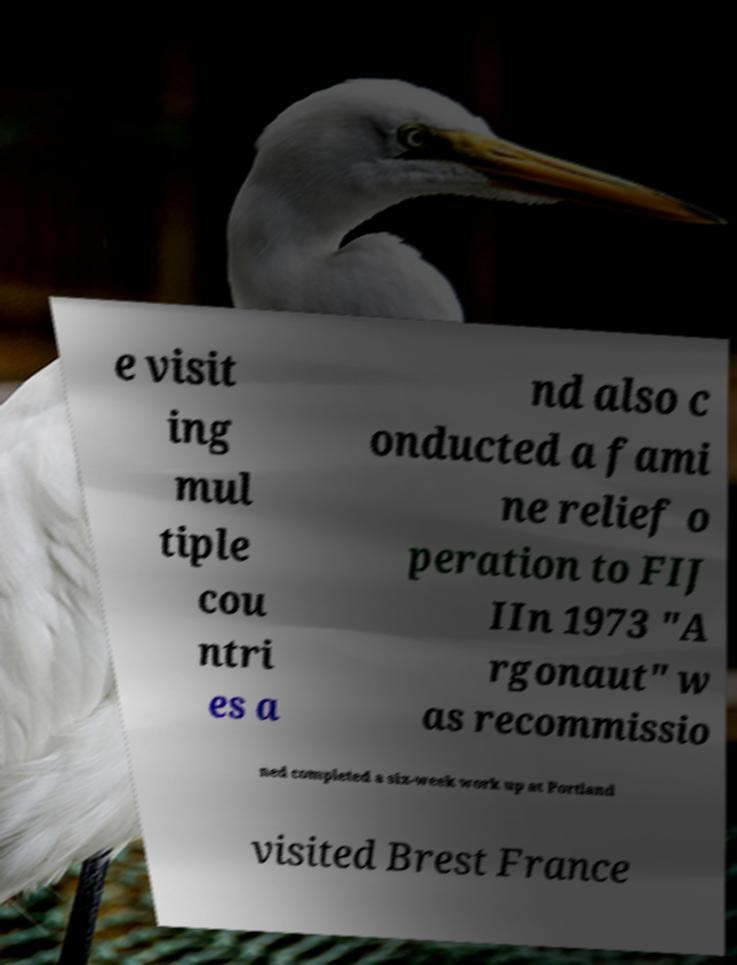Could you extract and type out the text from this image? e visit ing mul tiple cou ntri es a nd also c onducted a fami ne relief o peration to FIJ IIn 1973 "A rgonaut" w as recommissio ned completed a six-week work up at Portland visited Brest France 